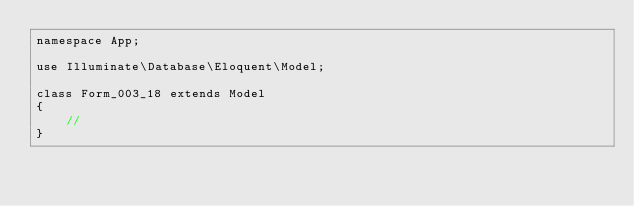Convert code to text. <code><loc_0><loc_0><loc_500><loc_500><_PHP_>namespace App;

use Illuminate\Database\Eloquent\Model;

class Form_003_18 extends Model
{
    //
}
</code> 